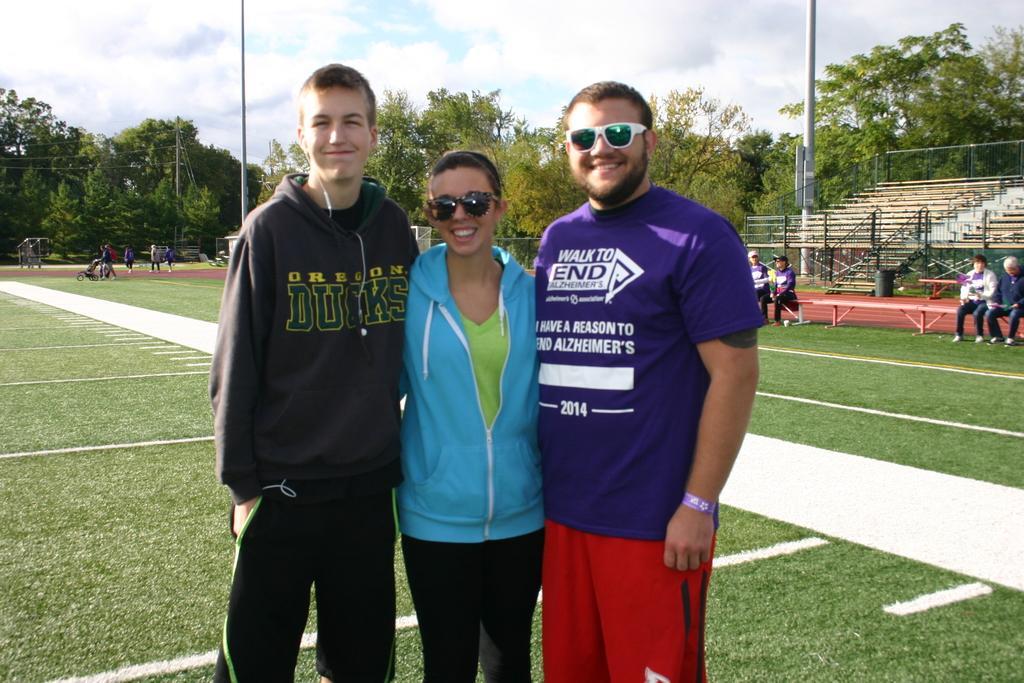In one or two sentences, can you explain what this image depicts? In front of the image there are three persons standing. There are two persons with goggles. At the bottom of the image on the ground there is grass. Behind those people there are few people sitting on the benches and some other people are walking. In the background there are trees, electrical poles with wires, steps and railings. At the top of the image there is sky with clouds. 